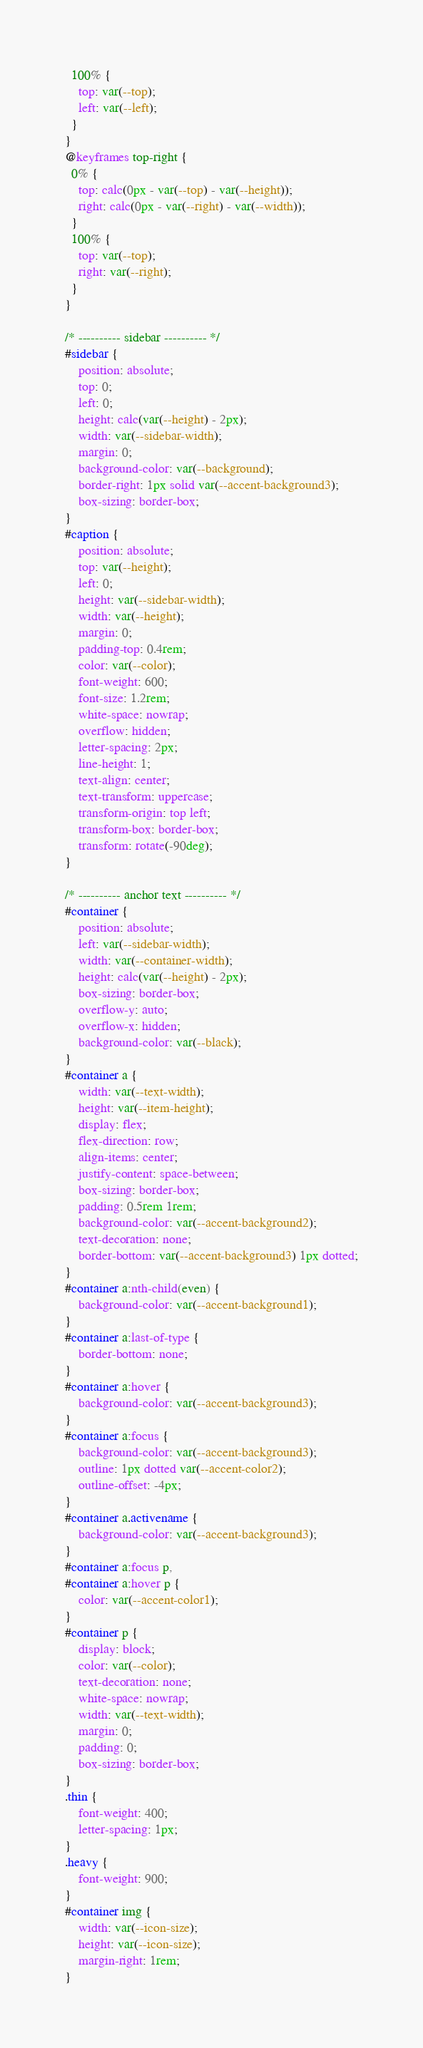Convert code to text. <code><loc_0><loc_0><loc_500><loc_500><_CSS_>  100% {
	top: var(--top);
	left: var(--left);
  }
}	
@keyframes top-right {
  0% {
	top: calc(0px - var(--top) - var(--height));
	right: calc(0px - var(--right) - var(--width));
  }
  100% {
	top: var(--top);
	right: var(--right);
  }
}	

/* ---------- sidebar ---------- */
#sidebar {
	position: absolute;
	top: 0;
	left: 0;
	height: calc(var(--height) - 2px);
	width: var(--sidebar-width);
	margin: 0;
	background-color: var(--background);
	border-right: 1px solid var(--accent-background3);
	box-sizing: border-box;
}
#caption {
	position: absolute;
	top: var(--height);
	left: 0;
	height: var(--sidebar-width);
	width: var(--height);
	margin: 0;
	padding-top: 0.4rem;
	color: var(--color);
	font-weight: 600;
	font-size: 1.2rem;
	white-space: nowrap;
	overflow: hidden;
	letter-spacing: 2px;
	line-height: 1;
	text-align: center;
	text-transform: uppercase;
	transform-origin: top left;
	transform-box: border-box;
	transform: rotate(-90deg); 
}

/* ---------- anchor text ---------- */
#container {
	position: absolute;
	left: var(--sidebar-width);
	width: var(--container-width);
	height: calc(var(--height) - 2px);
	box-sizing: border-box;
	overflow-y: auto;
	overflow-x: hidden;
	background-color: var(--black);
}
#container a {
	width: var(--text-width);
	height: var(--item-height);
	display: flex;
	flex-direction: row;
	align-items: center;
	justify-content: space-between;
	box-sizing: border-box;
	padding: 0.5rem 1rem;
	background-color: var(--accent-background2);
	text-decoration: none;
	border-bottom: var(--accent-background3) 1px dotted;
}
#container a:nth-child(even) {
	background-color: var(--accent-background1);
}
#container a:last-of-type {
	border-bottom: none;
}
#container a:hover {
	background-color: var(--accent-background3);
}
#container a:focus {
	background-color: var(--accent-background3);
	outline: 1px dotted var(--accent-color2);
	outline-offset: -4px;
}
#container a.activename {
	background-color: var(--accent-background3);
}
#container a:focus p,
#container a:hover p {
	color: var(--accent-color1);
}
#container p {
	display: block;
	color: var(--color);
	text-decoration: none;
	white-space: nowrap;
	width: var(--text-width);
	margin: 0;
	padding: 0;
	box-sizing: border-box;
}
.thin {
	font-weight: 400;
	letter-spacing: 1px;
}
.heavy {
	font-weight: 900;
}
#container img {
	width: var(--icon-size);
	height: var(--icon-size);
	margin-right: 1rem;
}
</code> 